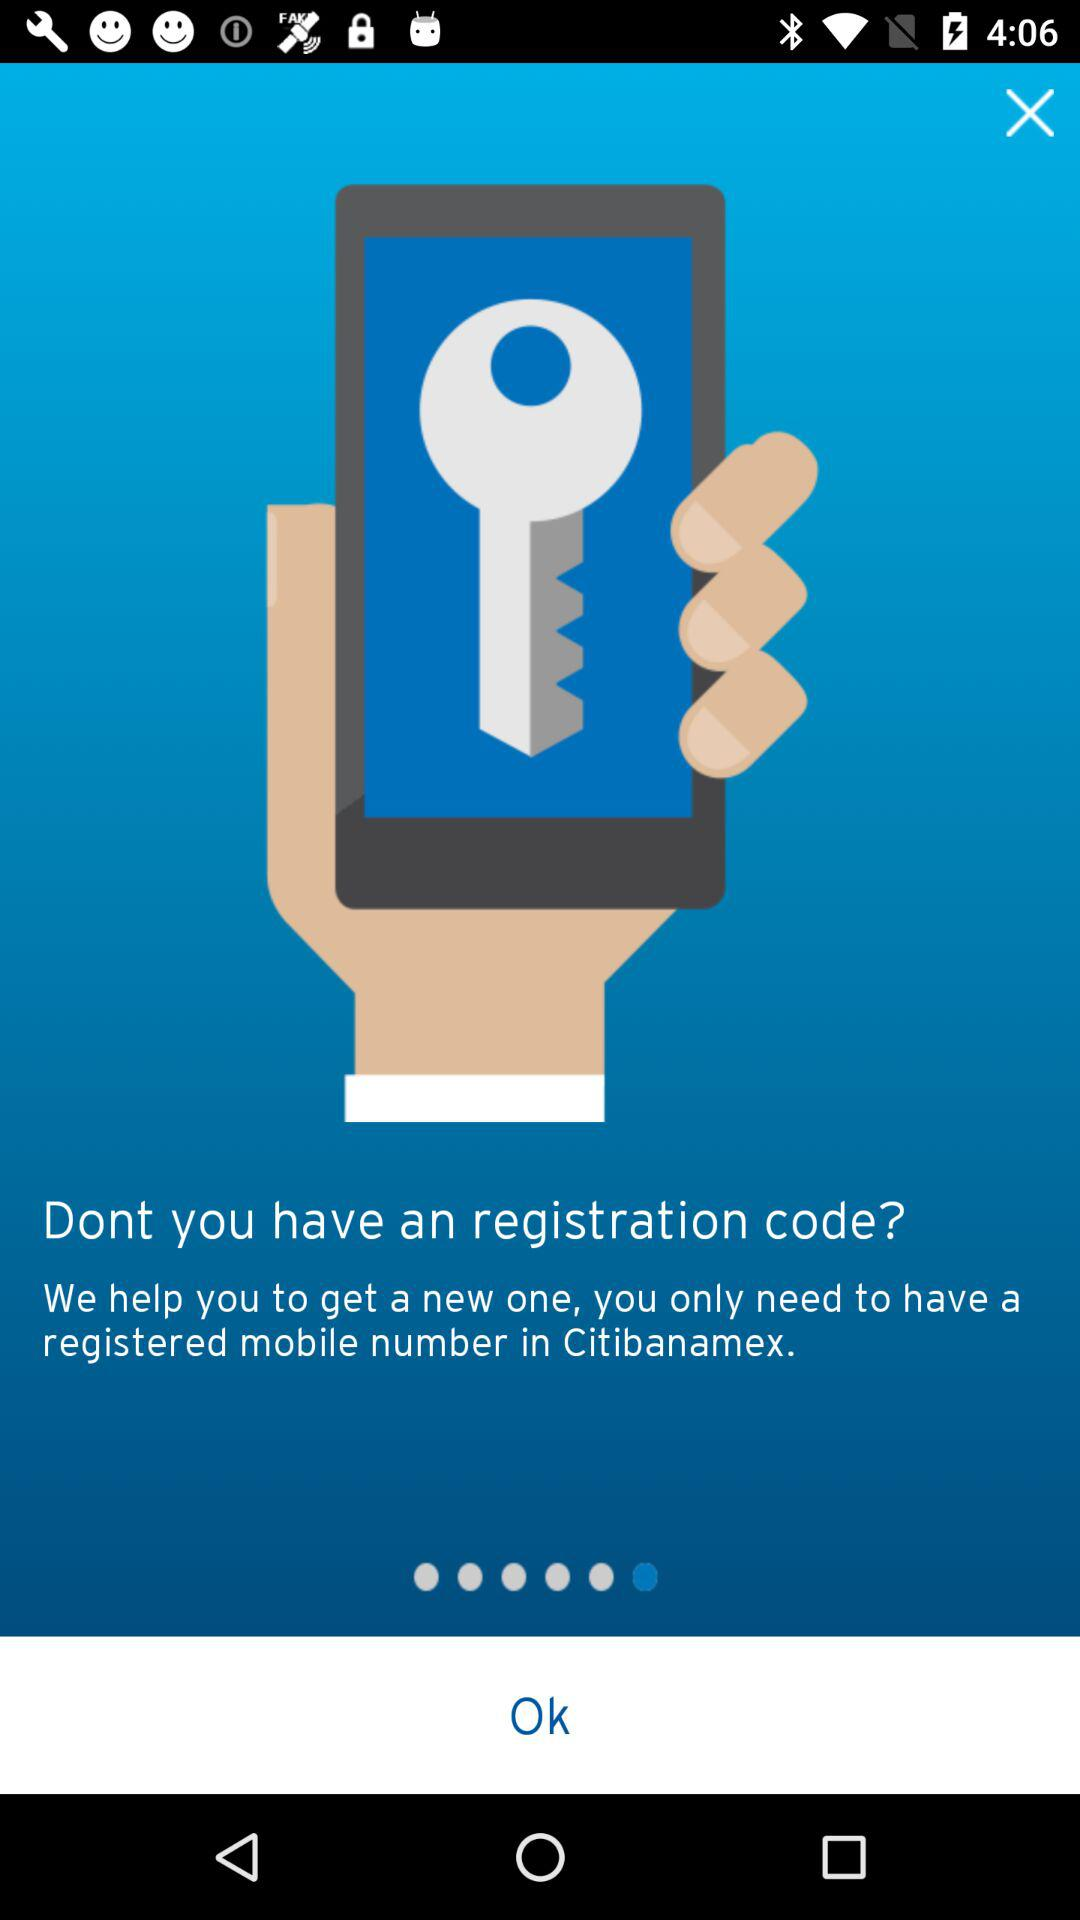What is the requirement to have a new registration code? The requirement is to have a registered mobile number in "Citibanamex". 